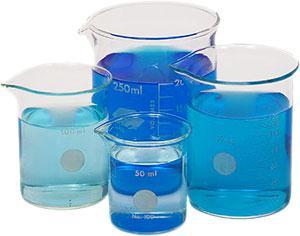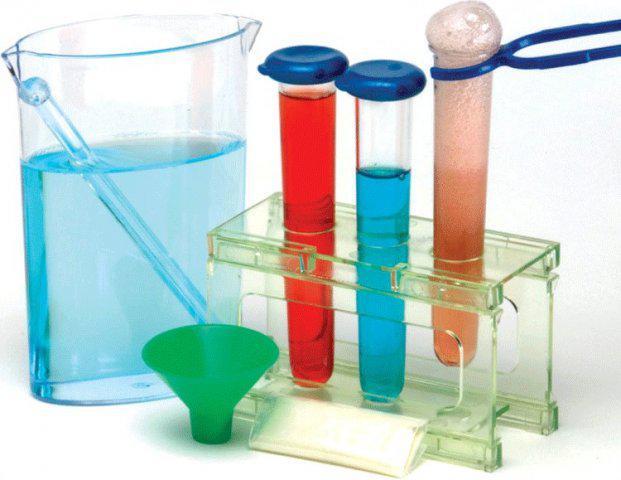The first image is the image on the left, the second image is the image on the right. For the images displayed, is the sentence "Four vases in the image on the left are filled with blue liquid." factually correct? Answer yes or no. Yes. 